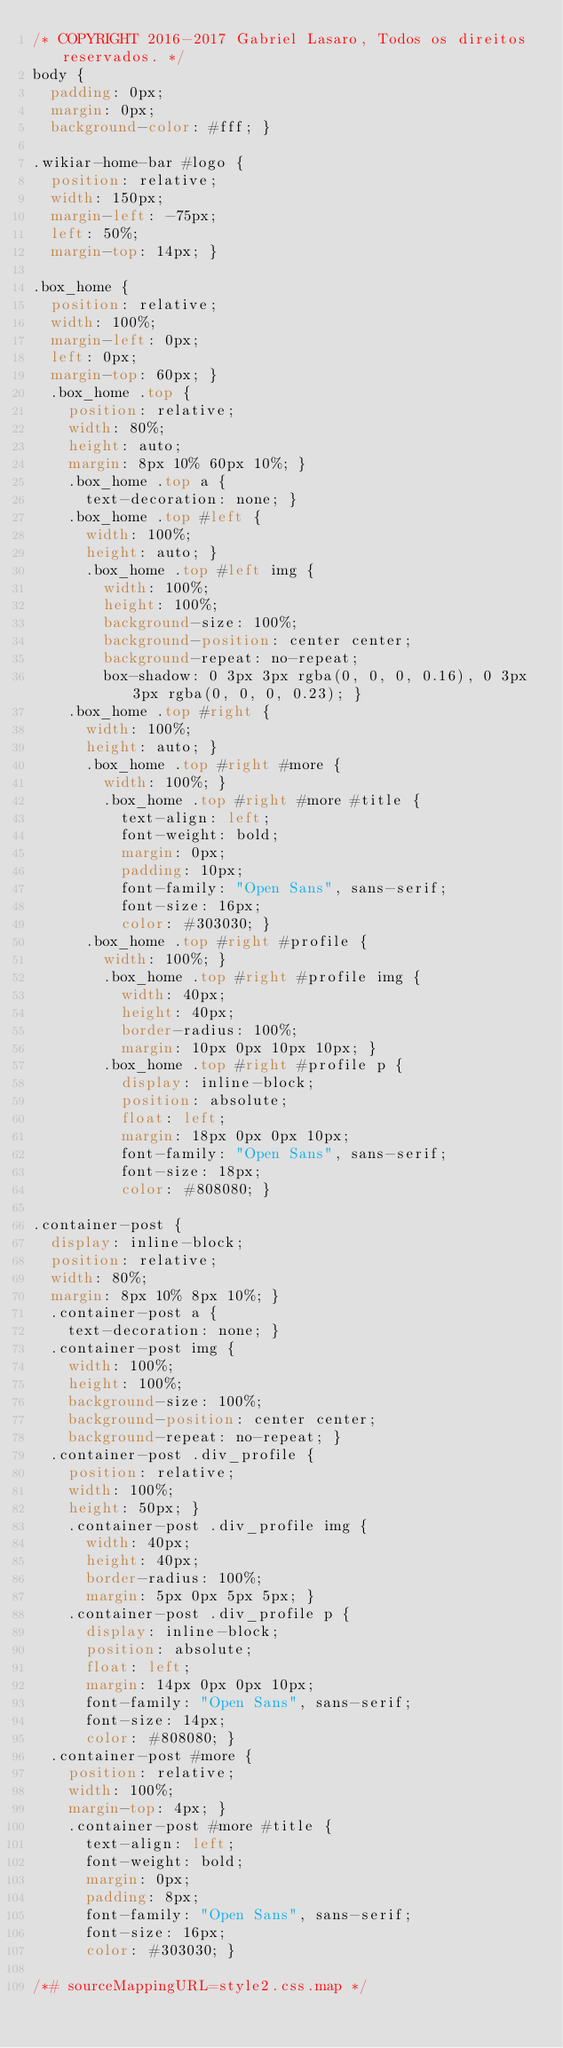Convert code to text. <code><loc_0><loc_0><loc_500><loc_500><_CSS_>/* COPYRIGHT 2016-2017 Gabriel Lasaro, Todos os direitos reservados. */
body {
  padding: 0px;
  margin: 0px;
  background-color: #fff; }

.wikiar-home-bar #logo {
  position: relative;
  width: 150px;
  margin-left: -75px;
  left: 50%;
  margin-top: 14px; }

.box_home {
  position: relative;
  width: 100%;
  margin-left: 0px;
  left: 0px;
  margin-top: 60px; }
  .box_home .top {
    position: relative;
    width: 80%;
    height: auto;
    margin: 8px 10% 60px 10%; }
    .box_home .top a {
      text-decoration: none; }
    .box_home .top #left {
      width: 100%;
      height: auto; }
      .box_home .top #left img {
        width: 100%;
        height: 100%;
        background-size: 100%;
        background-position: center center;
        background-repeat: no-repeat;
        box-shadow: 0 3px 3px rgba(0, 0, 0, 0.16), 0 3px 3px rgba(0, 0, 0, 0.23); }
    .box_home .top #right {
      width: 100%;
      height: auto; }
      .box_home .top #right #more {
        width: 100%; }
        .box_home .top #right #more #title {
          text-align: left;
          font-weight: bold;
          margin: 0px;
          padding: 10px;
          font-family: "Open Sans", sans-serif;
          font-size: 16px;
          color: #303030; }
      .box_home .top #right #profile {
        width: 100%; }
        .box_home .top #right #profile img {
          width: 40px;
          height: 40px;
          border-radius: 100%;
          margin: 10px 0px 10px 10px; }
        .box_home .top #right #profile p {
          display: inline-block;
          position: absolute;
          float: left;
          margin: 18px 0px 0px 10px;
          font-family: "Open Sans", sans-serif;
          font-size: 18px;
          color: #808080; }

.container-post {
  display: inline-block;
  position: relative;
  width: 80%;
  margin: 8px 10% 8px 10%; }
  .container-post a {
    text-decoration: none; }
  .container-post img {
    width: 100%;
    height: 100%;
    background-size: 100%;
    background-position: center center;
    background-repeat: no-repeat; }
  .container-post .div_profile {
    position: relative;
    width: 100%;
    height: 50px; }
    .container-post .div_profile img {
      width: 40px;
      height: 40px;
      border-radius: 100%;
      margin: 5px 0px 5px 5px; }
    .container-post .div_profile p {
      display: inline-block;
      position: absolute;
      float: left;
      margin: 14px 0px 0px 10px;
      font-family: "Open Sans", sans-serif;
      font-size: 14px;
      color: #808080; }
  .container-post #more {
    position: relative;
    width: 100%;
    margin-top: 4px; }
    .container-post #more #title {
      text-align: left;
      font-weight: bold;
      margin: 0px;
      padding: 8px;
      font-family: "Open Sans", sans-serif;
      font-size: 16px;
      color: #303030; }

/*# sourceMappingURL=style2.css.map */
</code> 